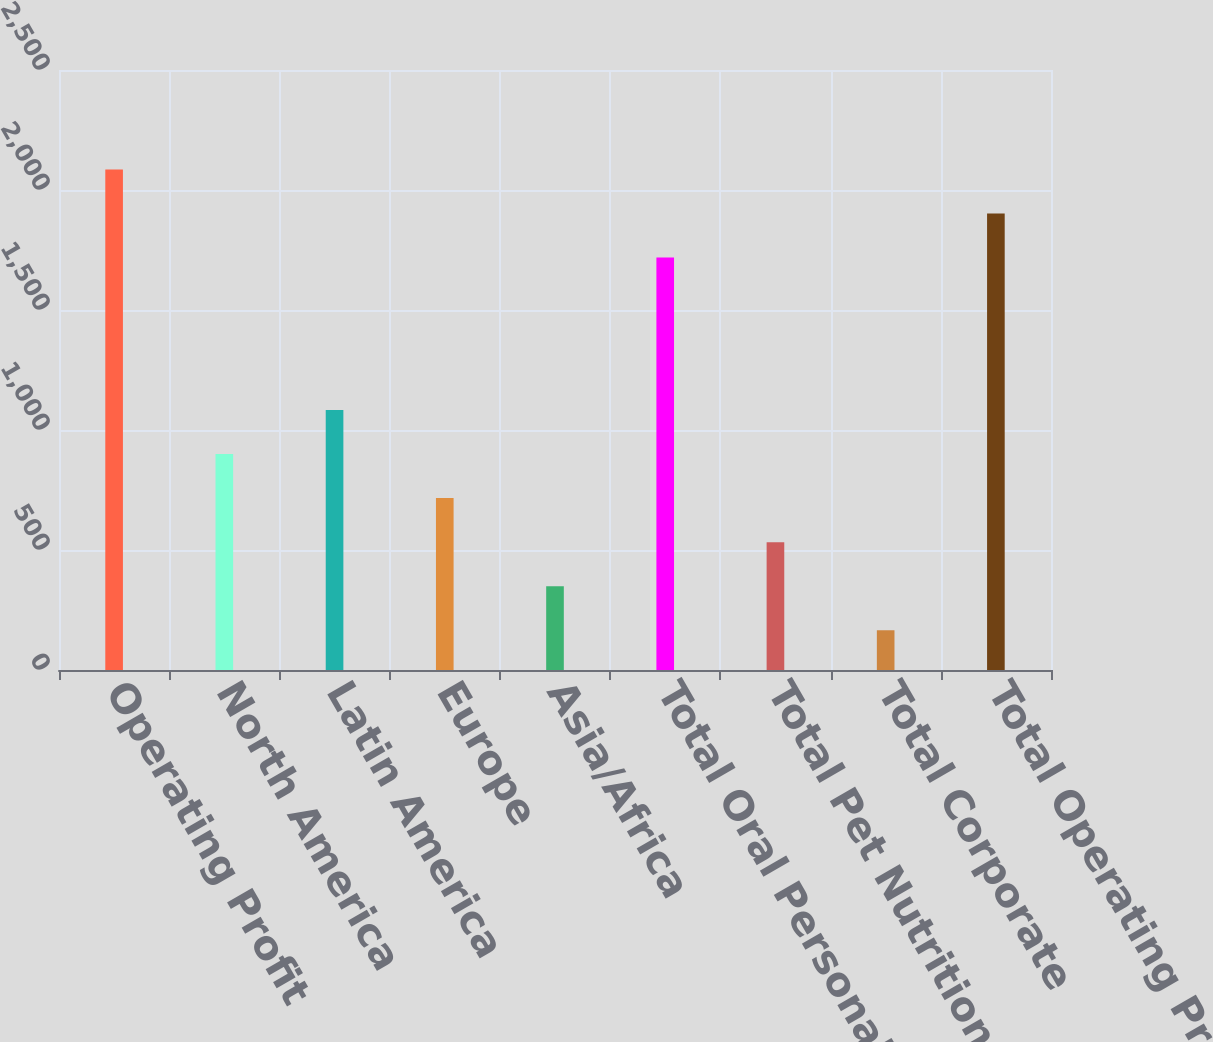Convert chart to OTSL. <chart><loc_0><loc_0><loc_500><loc_500><bar_chart><fcel>Operating Profit<fcel>North America<fcel>Latin America<fcel>Europe<fcel>Asia/Africa<fcel>Total Oral Personal Household<fcel>Total Pet Nutrition<fcel>Total Corporate<fcel>Total Operating Profit<nl><fcel>2085.38<fcel>899.76<fcel>1083.3<fcel>716.22<fcel>349.14<fcel>1718.3<fcel>532.68<fcel>165.6<fcel>1901.84<nl></chart> 